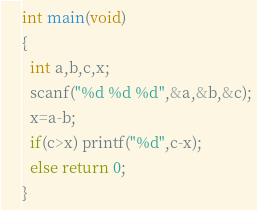Convert code to text. <code><loc_0><loc_0><loc_500><loc_500><_C_>int main(void)
{
  int a,b,c,x;
  scanf("%d %d %d",&a,&b,&c);
  x=a-b;
  if(c>x) printf("%d",c-x);
  else return 0;
}</code> 